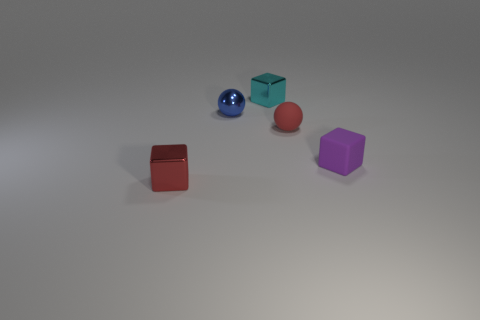Are there any spheres that have the same material as the cyan cube?
Your response must be concise. Yes. The block that is on the right side of the small object behind the ball behind the tiny rubber ball is what color?
Ensure brevity in your answer.  Purple. Is the color of the block that is behind the red matte object the same as the object on the left side of the tiny blue metallic thing?
Offer a very short reply. No. Are there any other things that are the same color as the metallic sphere?
Offer a very short reply. No. Are there fewer tiny blue metallic balls in front of the tiny blue sphere than tiny gray shiny blocks?
Make the answer very short. No. How many tiny matte objects are there?
Give a very brief answer. 2. Is the shape of the tiny purple thing the same as the tiny matte object that is behind the matte block?
Make the answer very short. No. Is the number of metal cubes that are to the right of the purple object less than the number of red rubber spheres that are in front of the red rubber object?
Offer a terse response. No. Is there any other thing that has the same shape as the small purple object?
Your answer should be compact. Yes. Is the red rubber thing the same shape as the purple thing?
Make the answer very short. No. 